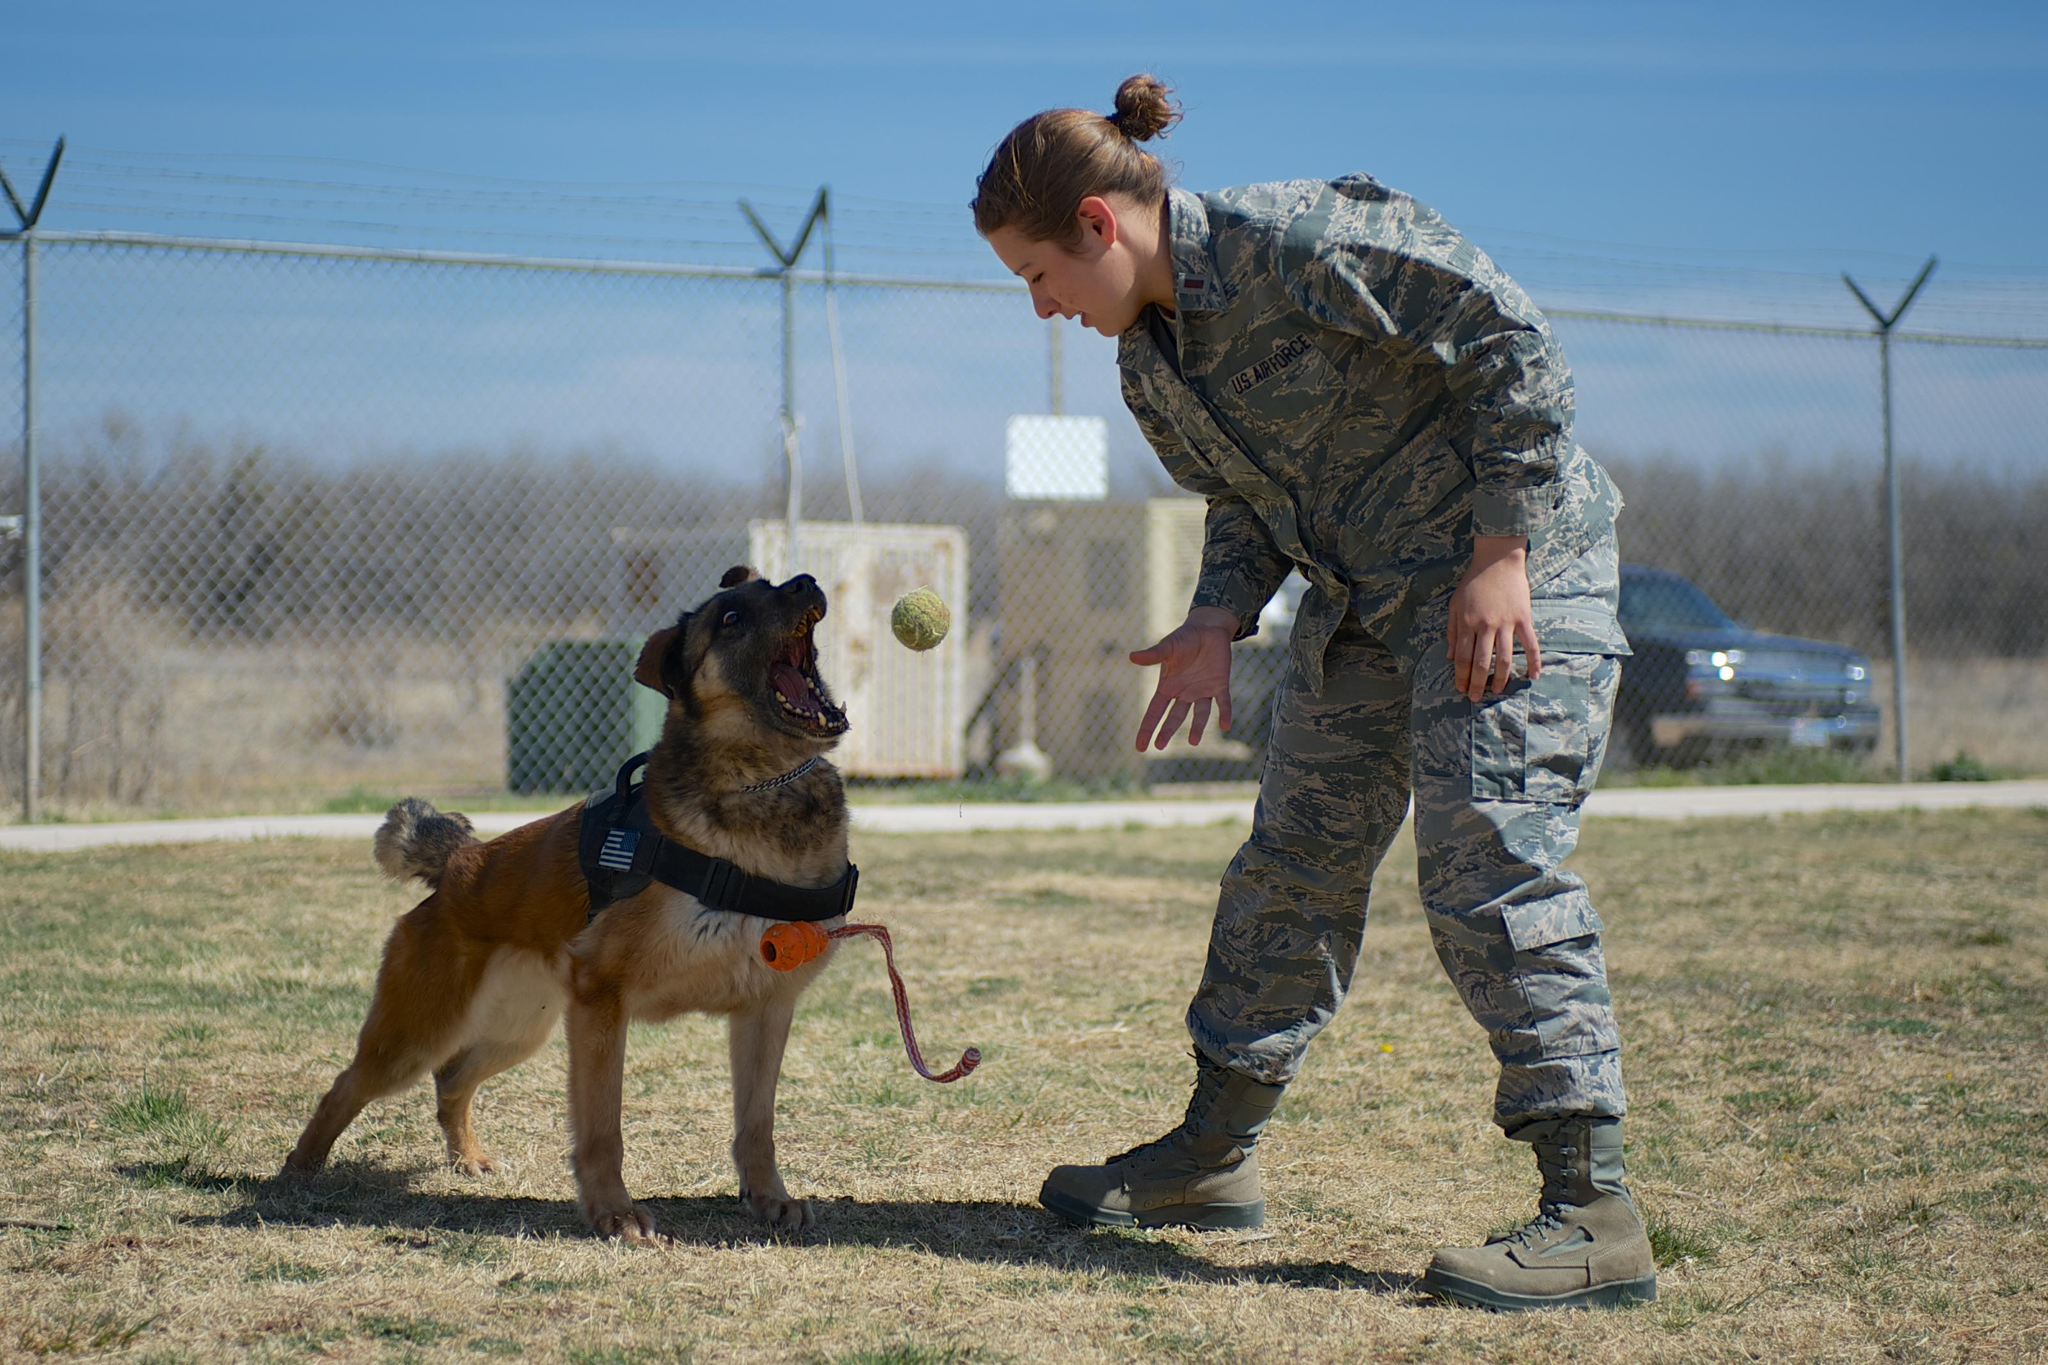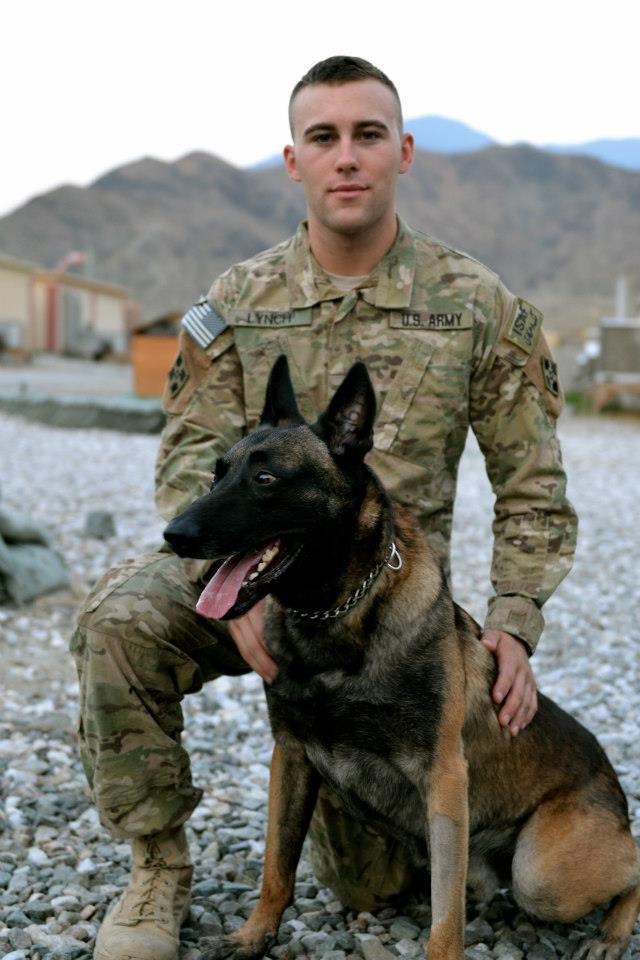The first image is the image on the left, the second image is the image on the right. Considering the images on both sides, is "The dog is showing its teeth to the person wearing camo." valid? Answer yes or no. Yes. The first image is the image on the left, the second image is the image on the right. Assess this claim about the two images: "A person in camo attire interacts with a dog in both images.". Correct or not? Answer yes or no. Yes. 